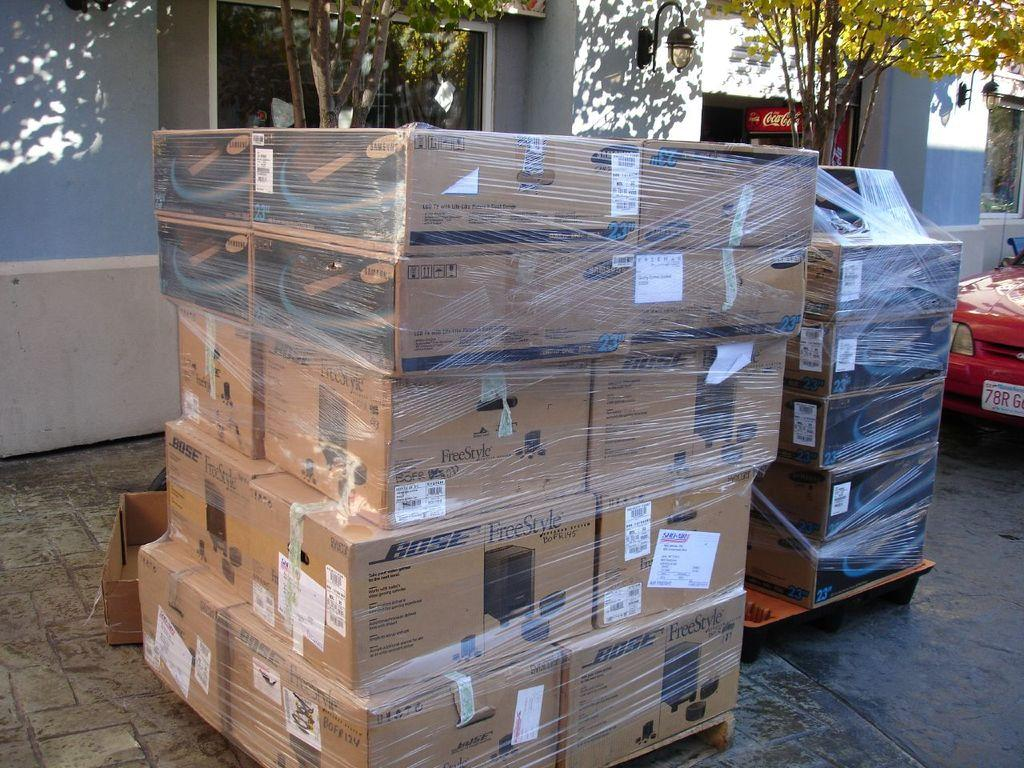Provide a one-sentence caption for the provided image. Many boxes with the word Bose on it. 